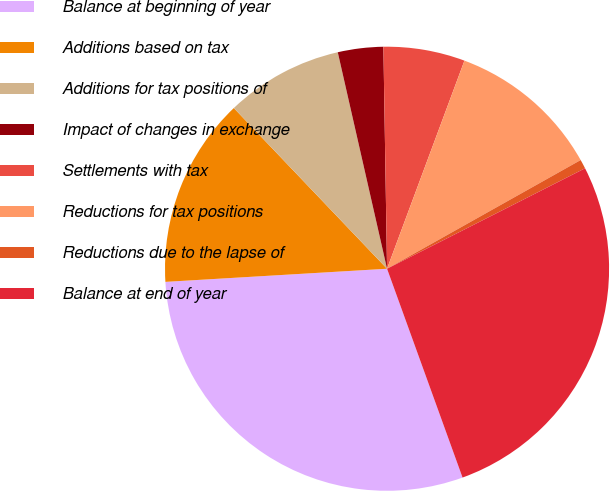Convert chart. <chart><loc_0><loc_0><loc_500><loc_500><pie_chart><fcel>Balance at beginning of year<fcel>Additions based on tax<fcel>Additions for tax positions of<fcel>Impact of changes in exchange<fcel>Settlements with tax<fcel>Reductions for tax positions<fcel>Reductions due to the lapse of<fcel>Balance at end of year<nl><fcel>29.58%<fcel>13.82%<fcel>8.56%<fcel>3.3%<fcel>5.93%<fcel>11.19%<fcel>0.67%<fcel>26.95%<nl></chart> 